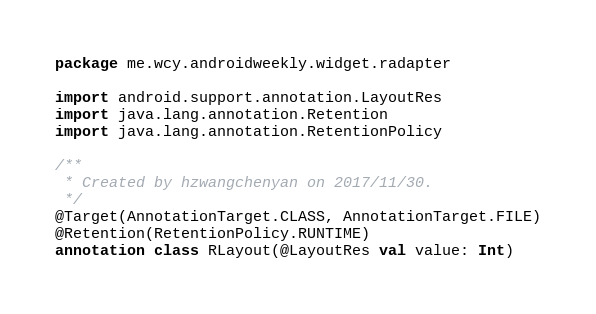Convert code to text. <code><loc_0><loc_0><loc_500><loc_500><_Kotlin_>package me.wcy.androidweekly.widget.radapter

import android.support.annotation.LayoutRes
import java.lang.annotation.Retention
import java.lang.annotation.RetentionPolicy

/**
 * Created by hzwangchenyan on 2017/11/30.
 */
@Target(AnnotationTarget.CLASS, AnnotationTarget.FILE)
@Retention(RetentionPolicy.RUNTIME)
annotation class RLayout(@LayoutRes val value: Int)
</code> 